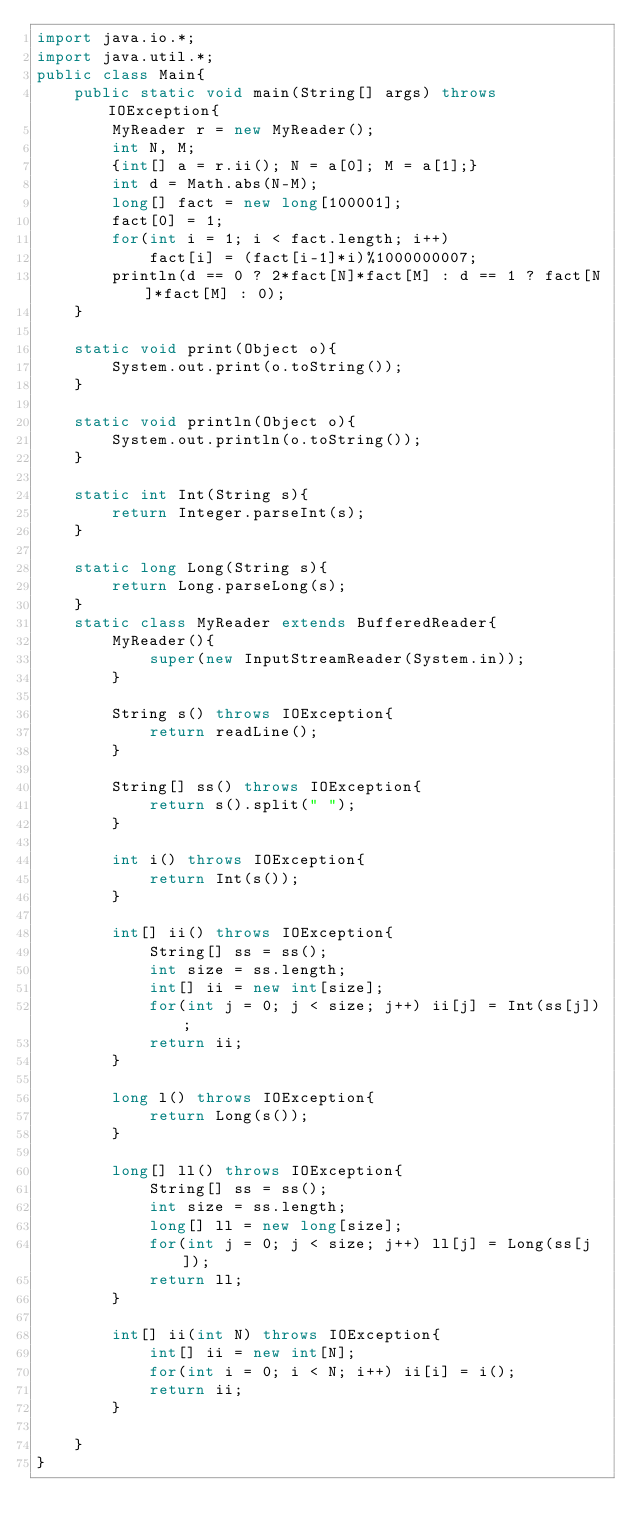Convert code to text. <code><loc_0><loc_0><loc_500><loc_500><_Java_>import java.io.*;
import java.util.*;
public class Main{
    public static void main(String[] args) throws IOException{
        MyReader r = new MyReader();    
        int N, M;
        {int[] a = r.ii(); N = a[0]; M = a[1];}
        int d = Math.abs(N-M);
        long[] fact = new long[100001];
        fact[0] = 1;
        for(int i = 1; i < fact.length; i++)
            fact[i] = (fact[i-1]*i)%1000000007;
        println(d == 0 ? 2*fact[N]*fact[M] : d == 1 ? fact[N]*fact[M] : 0);
    }

    static void print(Object o){
        System.out.print(o.toString());
    }

    static void println(Object o){
        System.out.println(o.toString());
    }

    static int Int(String s){
        return Integer.parseInt(s);
    }

    static long Long(String s){
        return Long.parseLong(s);
    }
    static class MyReader extends BufferedReader{
        MyReader(){
            super(new InputStreamReader(System.in));
        }

        String s() throws IOException{
            return readLine();
        }

        String[] ss() throws IOException{
            return s().split(" ");
        }

        int i() throws IOException{
            return Int(s());
        }

        int[] ii() throws IOException{
            String[] ss = ss();
            int size = ss.length;
            int[] ii = new int[size];
            for(int j = 0; j < size; j++) ii[j] = Int(ss[j]);
            return ii;
        }

        long l() throws IOException{
            return Long(s());
        }

        long[] ll() throws IOException{
            String[] ss = ss();
            int size = ss.length;
            long[] ll = new long[size];
            for(int j = 0; j < size; j++) ll[j] = Long(ss[j]);            
            return ll;
        }

        int[] ii(int N) throws IOException{
            int[] ii = new int[N];
            for(int i = 0; i < N; i++) ii[i] = i();
            return ii;
        }

    }
}</code> 